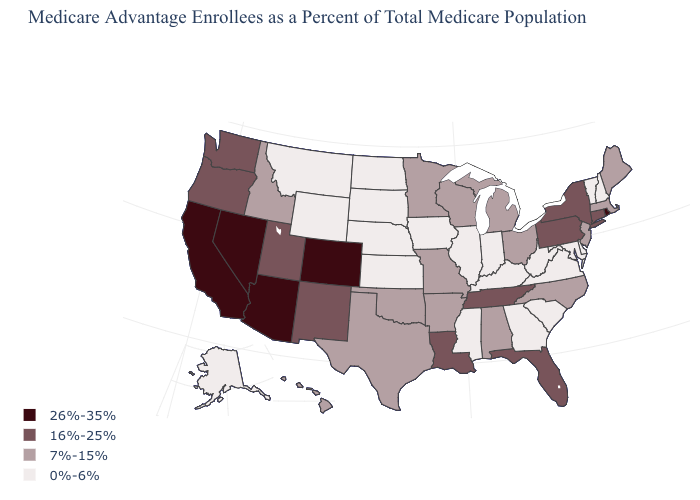What is the value of Maryland?
Give a very brief answer. 0%-6%. What is the value of Nebraska?
Write a very short answer. 0%-6%. What is the highest value in the USA?
Keep it brief. 26%-35%. Name the states that have a value in the range 0%-6%?
Be succinct. Alaska, Delaware, Georgia, Iowa, Illinois, Indiana, Kansas, Kentucky, Maryland, Mississippi, Montana, North Dakota, Nebraska, New Hampshire, South Carolina, South Dakota, Virginia, Vermont, West Virginia, Wyoming. What is the lowest value in the USA?
Quick response, please. 0%-6%. Is the legend a continuous bar?
Answer briefly. No. Name the states that have a value in the range 7%-15%?
Write a very short answer. Alabama, Arkansas, Hawaii, Idaho, Massachusetts, Maine, Michigan, Minnesota, Missouri, North Carolina, New Jersey, Ohio, Oklahoma, Texas, Wisconsin. Does the map have missing data?
Answer briefly. No. Does the first symbol in the legend represent the smallest category?
Concise answer only. No. Name the states that have a value in the range 16%-25%?
Quick response, please. Connecticut, Florida, Louisiana, New Mexico, New York, Oregon, Pennsylvania, Tennessee, Utah, Washington. What is the highest value in the MidWest ?
Answer briefly. 7%-15%. Name the states that have a value in the range 0%-6%?
Answer briefly. Alaska, Delaware, Georgia, Iowa, Illinois, Indiana, Kansas, Kentucky, Maryland, Mississippi, Montana, North Dakota, Nebraska, New Hampshire, South Carolina, South Dakota, Virginia, Vermont, West Virginia, Wyoming. What is the value of Colorado?
Write a very short answer. 26%-35%. Among the states that border Oklahoma , which have the lowest value?
Give a very brief answer. Kansas. Does Connecticut have the lowest value in the USA?
Concise answer only. No. 